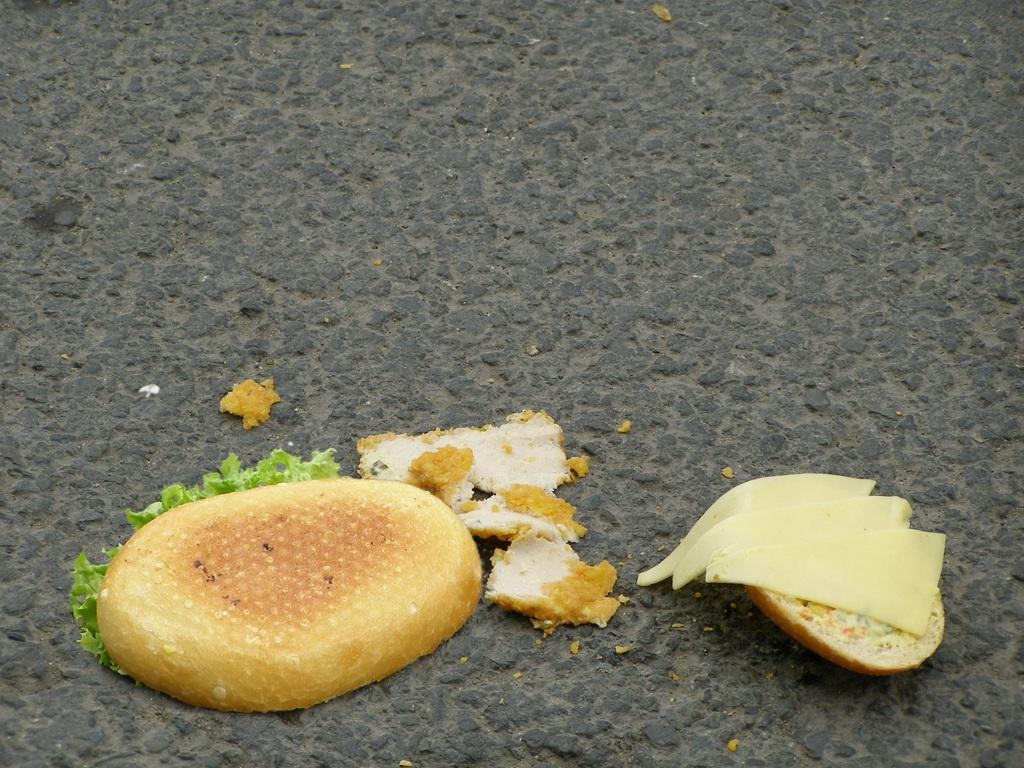What type of food items can be seen on the road in the image? There are bread pieces and cheese on the road in the image. What else can be seen on the road besides food items? There are leaves on the road. What type of fruit can be seen hanging from the trees in the image? There are no trees or fruit visible in the image; it only shows bread pieces, cheese, and leaves on the road. 